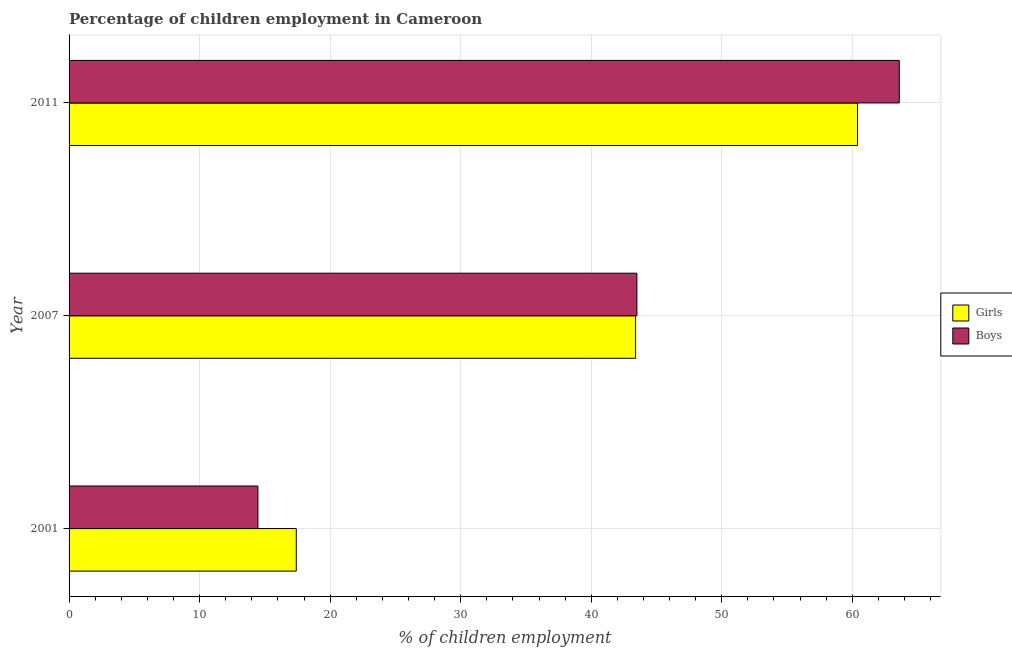Are the number of bars per tick equal to the number of legend labels?
Your answer should be compact. Yes. How many bars are there on the 1st tick from the top?
Offer a terse response. 2. What is the label of the 1st group of bars from the top?
Your answer should be compact. 2011. In how many cases, is the number of bars for a given year not equal to the number of legend labels?
Offer a very short reply. 0. What is the percentage of employed boys in 2011?
Your answer should be very brief. 63.6. Across all years, what is the maximum percentage of employed boys?
Ensure brevity in your answer.  63.6. Across all years, what is the minimum percentage of employed boys?
Offer a very short reply. 14.47. In which year was the percentage of employed boys minimum?
Your answer should be compact. 2001. What is the total percentage of employed boys in the graph?
Offer a terse response. 121.57. What is the difference between the percentage of employed girls in 2001 and that in 2011?
Offer a very short reply. -42.99. What is the average percentage of employed girls per year?
Provide a succinct answer. 40.4. In the year 2011, what is the difference between the percentage of employed girls and percentage of employed boys?
Your answer should be very brief. -3.2. In how many years, is the percentage of employed girls greater than 8 %?
Your answer should be compact. 3. What is the ratio of the percentage of employed boys in 2001 to that in 2007?
Provide a short and direct response. 0.33. Is the difference between the percentage of employed boys in 2001 and 2007 greater than the difference between the percentage of employed girls in 2001 and 2007?
Offer a terse response. No. What is the difference between the highest and the second highest percentage of employed boys?
Provide a succinct answer. 20.1. What is the difference between the highest and the lowest percentage of employed girls?
Make the answer very short. 42.99. What does the 1st bar from the top in 2001 represents?
Provide a short and direct response. Boys. What does the 1st bar from the bottom in 2011 represents?
Provide a succinct answer. Girls. How many bars are there?
Ensure brevity in your answer.  6. Are all the bars in the graph horizontal?
Your answer should be compact. Yes. How many years are there in the graph?
Make the answer very short. 3. What is the difference between two consecutive major ticks on the X-axis?
Offer a terse response. 10. Are the values on the major ticks of X-axis written in scientific E-notation?
Keep it short and to the point. No. Does the graph contain any zero values?
Ensure brevity in your answer.  No. Does the graph contain grids?
Make the answer very short. Yes. Where does the legend appear in the graph?
Ensure brevity in your answer.  Center right. How are the legend labels stacked?
Make the answer very short. Vertical. What is the title of the graph?
Give a very brief answer. Percentage of children employment in Cameroon. What is the label or title of the X-axis?
Your answer should be very brief. % of children employment. What is the % of children employment in Girls in 2001?
Provide a succinct answer. 17.41. What is the % of children employment in Boys in 2001?
Provide a succinct answer. 14.47. What is the % of children employment of Girls in 2007?
Keep it short and to the point. 43.4. What is the % of children employment in Boys in 2007?
Your answer should be compact. 43.5. What is the % of children employment of Girls in 2011?
Keep it short and to the point. 60.4. What is the % of children employment of Boys in 2011?
Your answer should be compact. 63.6. Across all years, what is the maximum % of children employment of Girls?
Your answer should be very brief. 60.4. Across all years, what is the maximum % of children employment in Boys?
Ensure brevity in your answer.  63.6. Across all years, what is the minimum % of children employment of Girls?
Provide a succinct answer. 17.41. Across all years, what is the minimum % of children employment in Boys?
Provide a short and direct response. 14.47. What is the total % of children employment of Girls in the graph?
Offer a terse response. 121.21. What is the total % of children employment of Boys in the graph?
Provide a short and direct response. 121.57. What is the difference between the % of children employment of Girls in 2001 and that in 2007?
Keep it short and to the point. -25.99. What is the difference between the % of children employment of Boys in 2001 and that in 2007?
Your response must be concise. -29.03. What is the difference between the % of children employment in Girls in 2001 and that in 2011?
Make the answer very short. -42.99. What is the difference between the % of children employment of Boys in 2001 and that in 2011?
Provide a short and direct response. -49.13. What is the difference between the % of children employment of Girls in 2007 and that in 2011?
Your answer should be very brief. -17. What is the difference between the % of children employment of Boys in 2007 and that in 2011?
Keep it short and to the point. -20.1. What is the difference between the % of children employment of Girls in 2001 and the % of children employment of Boys in 2007?
Provide a short and direct response. -26.09. What is the difference between the % of children employment in Girls in 2001 and the % of children employment in Boys in 2011?
Offer a terse response. -46.19. What is the difference between the % of children employment of Girls in 2007 and the % of children employment of Boys in 2011?
Keep it short and to the point. -20.2. What is the average % of children employment of Girls per year?
Your response must be concise. 40.4. What is the average % of children employment in Boys per year?
Your response must be concise. 40.52. In the year 2001, what is the difference between the % of children employment of Girls and % of children employment of Boys?
Keep it short and to the point. 2.94. In the year 2011, what is the difference between the % of children employment in Girls and % of children employment in Boys?
Provide a short and direct response. -3.2. What is the ratio of the % of children employment in Girls in 2001 to that in 2007?
Offer a terse response. 0.4. What is the ratio of the % of children employment in Boys in 2001 to that in 2007?
Offer a very short reply. 0.33. What is the ratio of the % of children employment in Girls in 2001 to that in 2011?
Give a very brief answer. 0.29. What is the ratio of the % of children employment in Boys in 2001 to that in 2011?
Give a very brief answer. 0.23. What is the ratio of the % of children employment in Girls in 2007 to that in 2011?
Offer a very short reply. 0.72. What is the ratio of the % of children employment of Boys in 2007 to that in 2011?
Keep it short and to the point. 0.68. What is the difference between the highest and the second highest % of children employment of Girls?
Ensure brevity in your answer.  17. What is the difference between the highest and the second highest % of children employment in Boys?
Keep it short and to the point. 20.1. What is the difference between the highest and the lowest % of children employment in Girls?
Keep it short and to the point. 42.99. What is the difference between the highest and the lowest % of children employment of Boys?
Keep it short and to the point. 49.13. 